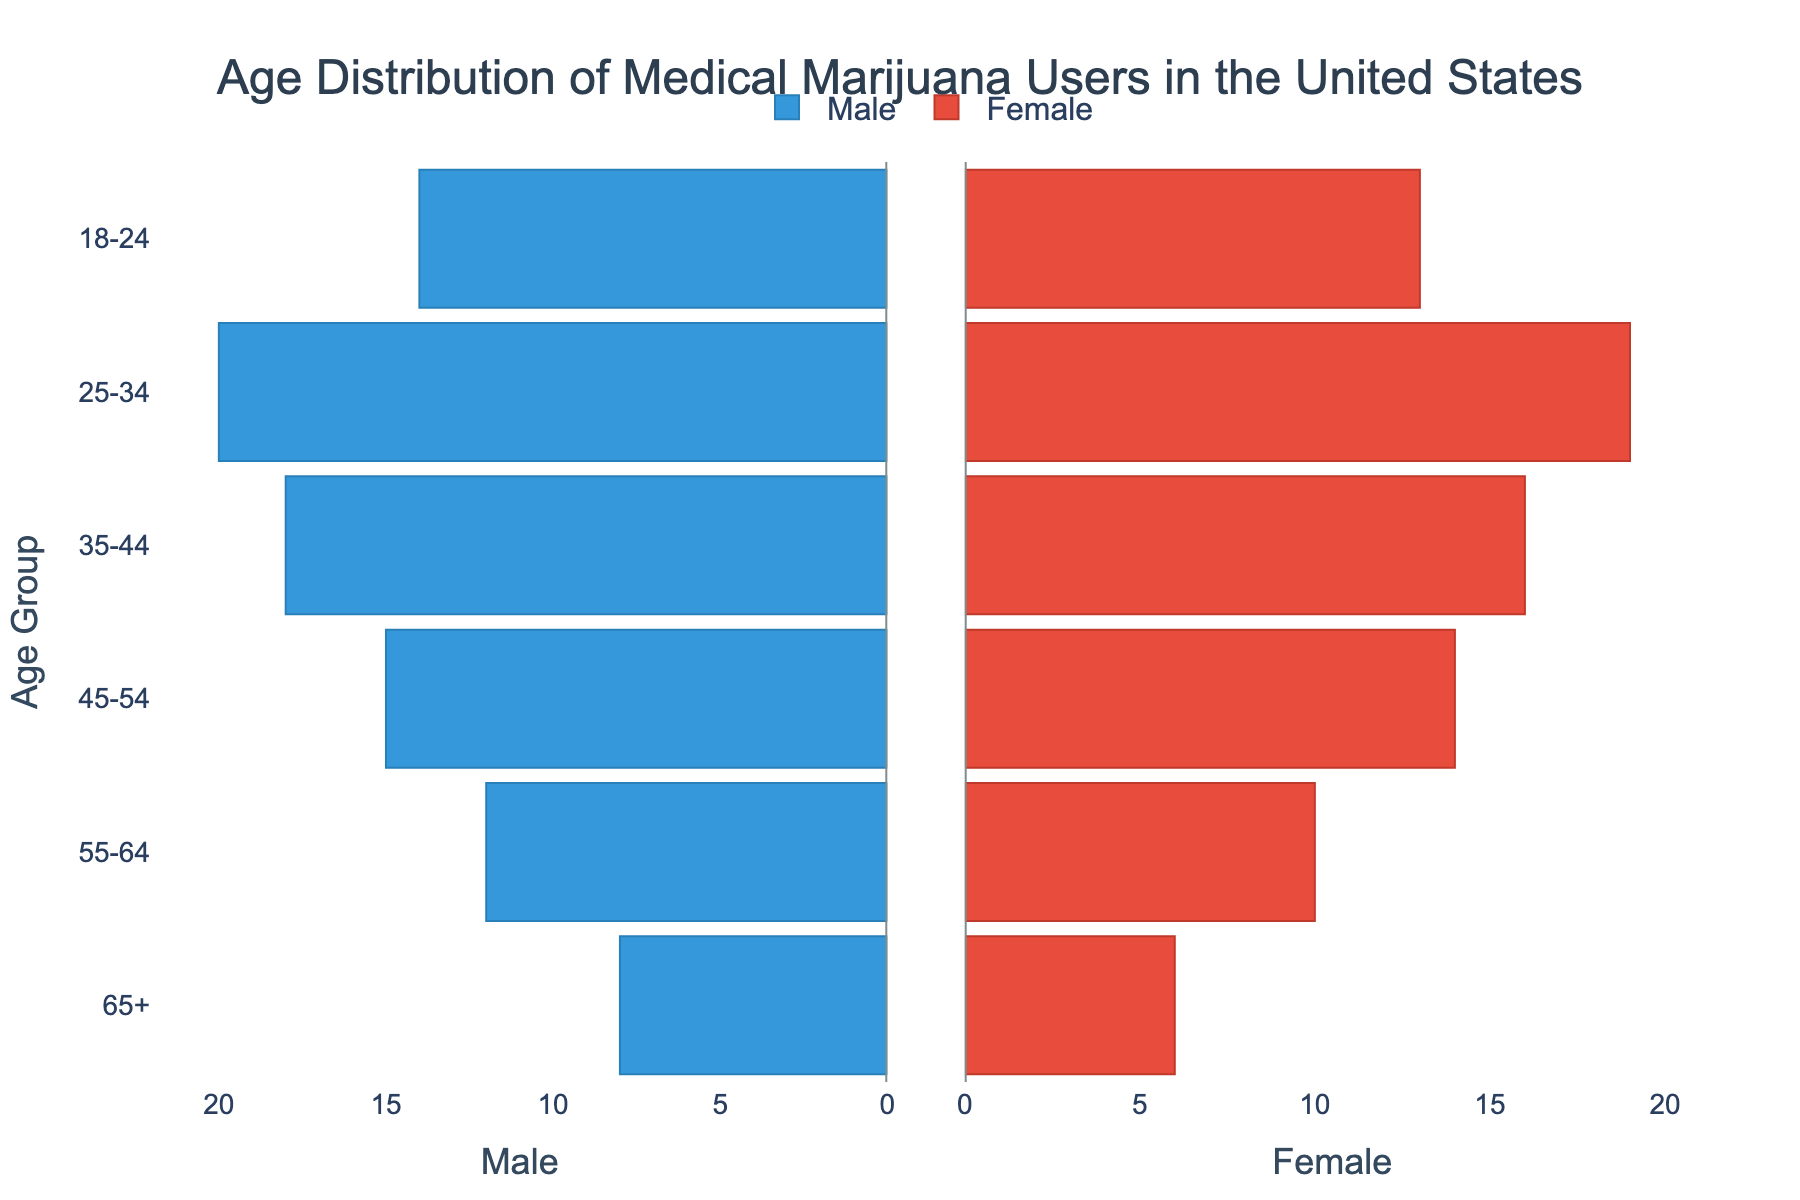What's the title of the figure? The title of the figure is at the top and it reads, "Age Distribution of Medical Marijuana Users in the United States".
Answer: Age Distribution of Medical Marijuana Users in the United States Which age group has the highest number of male users? By looking at the bar lengths on the male side, the age group 25-34 has the longest bar, indicating it has the highest number of male users.
Answer: 25-34 What is the total number of female users in the 45-54 age group? The bar for females in the 45-54 age group is marked at 14, so the total number of female users in that group is 14.
Answer: 14 How does the number of male users in the 55-64 age group compare to females in the same group? The bar lengths for the 55-64 age group show 12 male users and 10 female users, indicating there are 2 more male users than female users.
Answer: 2 more males than females Which age group has the closest number of male and female users? The bars for the 25-34 age group are the closest in length among all age groups, with males at 20 and females at 19, a difference of just 1.
Answer: 25-34 What is the total number of users (both male and female) in the 18-24 age group? The male users are 14 and the female users are 13 in the 18-24 age group. Adding them together gives a total of 14 + 13 = 27 users.
Answer: 27 How many more male users are there in the 35-44 age group compared to the 65+ age group? There are 18 male users in the 35-44 age group and 8 male users in the 65+ age group. The difference is 18 - 8 = 10 more male users in the 35-44 age group.
Answer: 10 Which gender has more users in the youngest age group (18-24)? Comparing the bar lengths for the 18-24 age group, the number of male users (14) is slightly higher than female users (13).
Answer: Male Is there any age group where the number of male users is exactly twice the number of female users? For each age group, divide the number of male users by the number of female users: 
- 65+: 8/6 ≈ 1.33
- 55-64: 12/10 = 1.2
- 45-54: 15/14 ≈ 1.07
- 35-44: 18/16 = 1.125
- 25-34: 20/19 ≈ 1.05
- 18-24: 14/13 ≈ 1.08 
None of the ratios are precisely 2.
Answer: No 